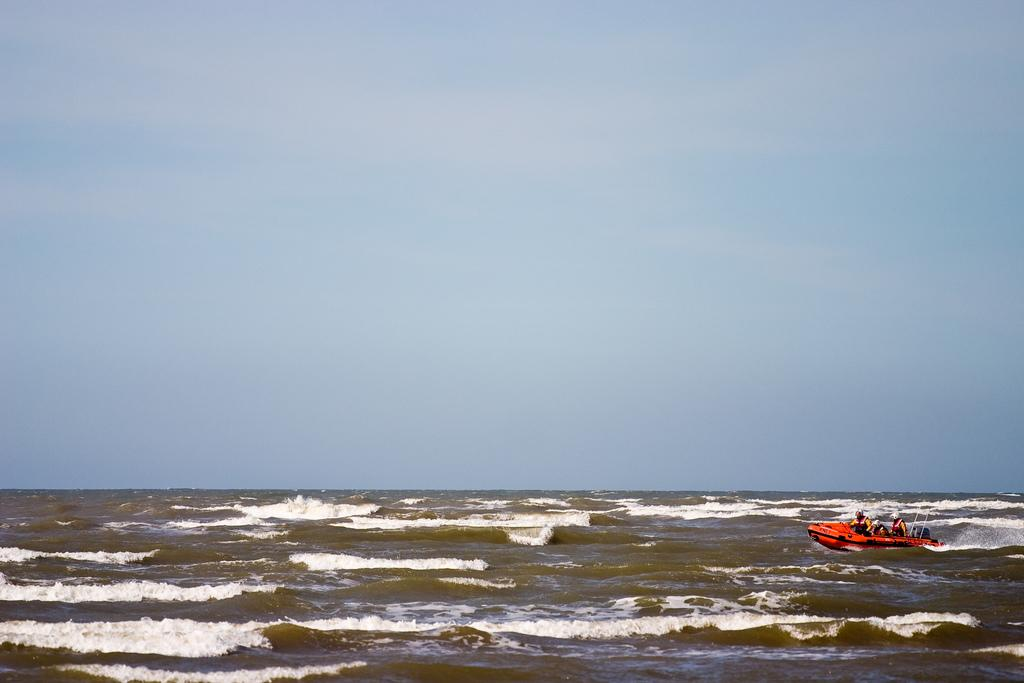What is located on the right side of the image? There is water on the right side of the image. What can be seen in the water? There is a red color boat in the water. What is the boat being used for in the image? There are people traveling in the boat. What is visible at the top of the image? The sky is visible at the top of the image. Can you tell me how many ants are crawling on the boat in the image? There are no ants present on the boat in the image. What type of flowers can be seen growing near the water in the image? There are no flowers visible in the image; it only features a boat in the water with people traveling in it. 